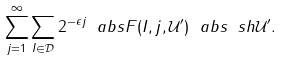<formula> <loc_0><loc_0><loc_500><loc_500>\sum _ { j = 1 } ^ { \infty } \sum _ { I \in \mathcal { D } } 2 ^ { - \epsilon j } \ a b s { F ( I , j , \mathcal { U } ^ { \prime } ) } \ a b s { \ s h { \mathcal { U } ^ { \prime } } } .</formula> 